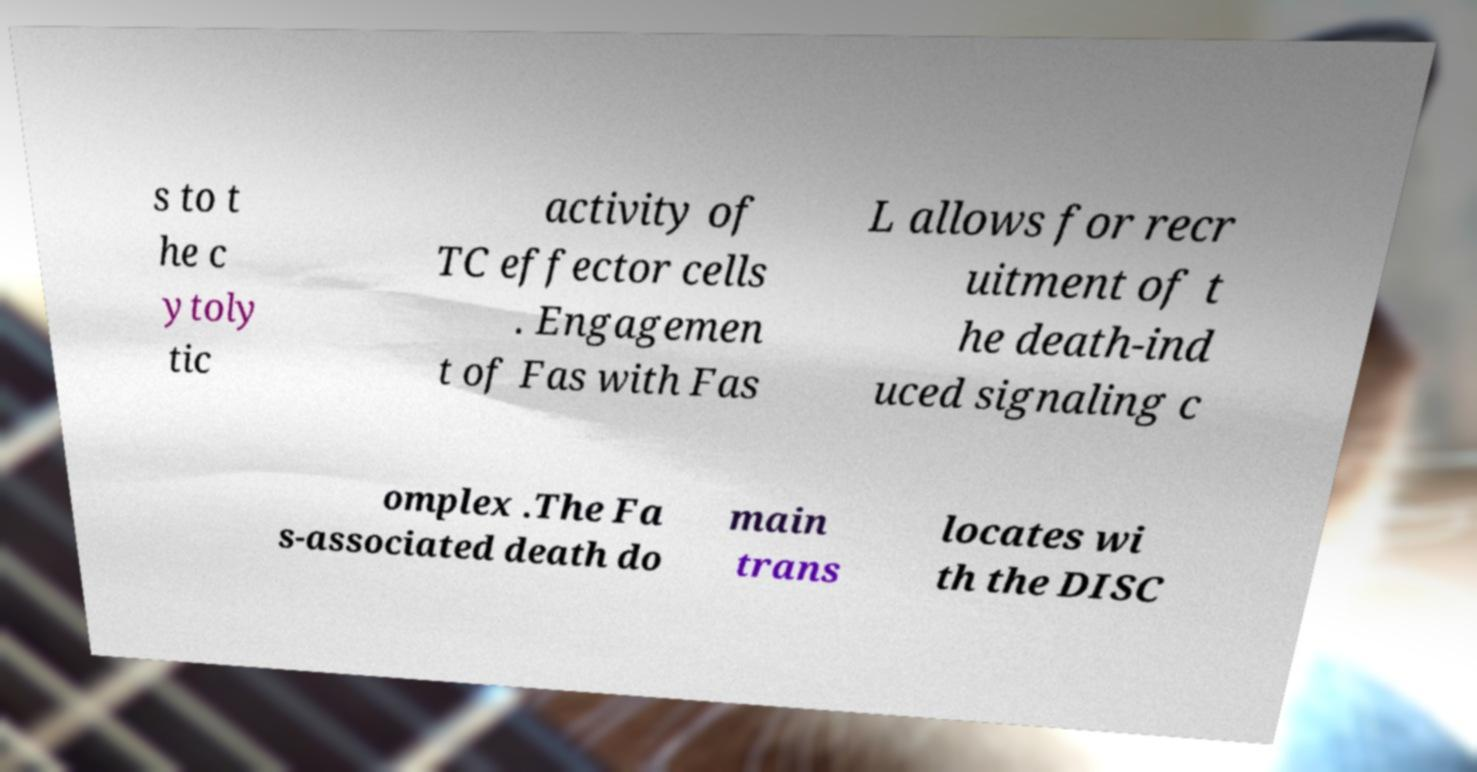Could you assist in decoding the text presented in this image and type it out clearly? s to t he c ytoly tic activity of TC effector cells . Engagemen t of Fas with Fas L allows for recr uitment of t he death-ind uced signaling c omplex .The Fa s-associated death do main trans locates wi th the DISC 